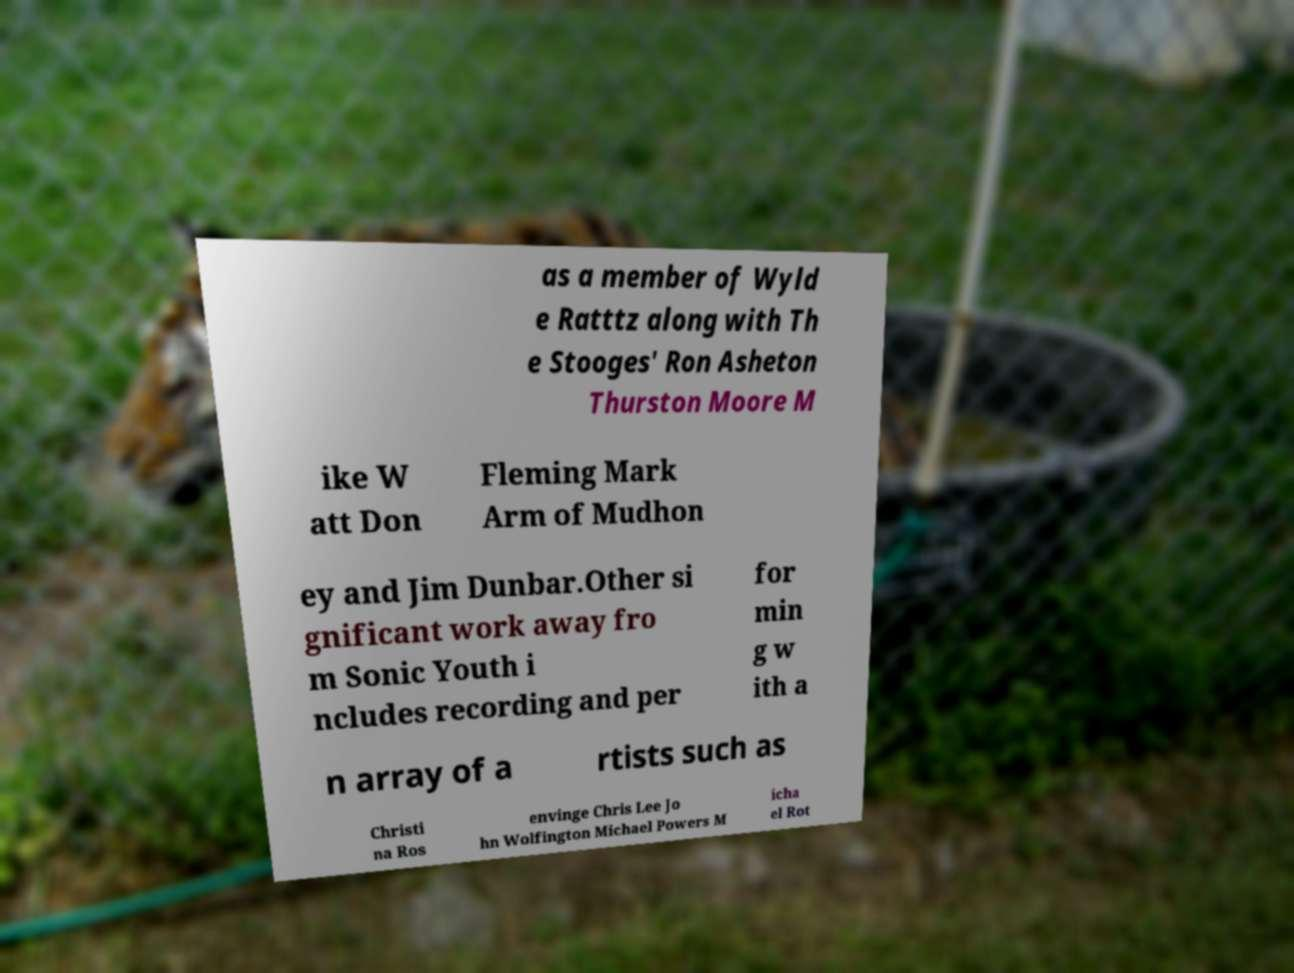I need the written content from this picture converted into text. Can you do that? as a member of Wyld e Ratttz along with Th e Stooges' Ron Asheton Thurston Moore M ike W att Don Fleming Mark Arm of Mudhon ey and Jim Dunbar.Other si gnificant work away fro m Sonic Youth i ncludes recording and per for min g w ith a n array of a rtists such as Christi na Ros envinge Chris Lee Jo hn Wolfington Michael Powers M icha el Rot 